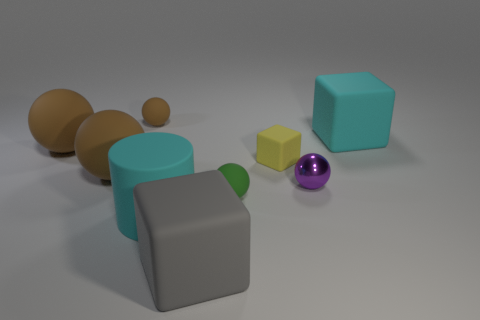Are there any other things that are the same material as the tiny purple sphere?
Give a very brief answer. No. There is a big rubber cylinder; what number of large cyan rubber things are behind it?
Offer a very short reply. 1. How many other things are the same size as the purple object?
Offer a terse response. 3. What is the size of the green rubber object that is the same shape as the small brown thing?
Offer a terse response. Small. What shape is the matte object that is right of the tiny purple shiny sphere?
Provide a short and direct response. Cube. There is a object that is behind the big matte cube behind the large cyan cylinder; what color is it?
Make the answer very short. Brown. How many things are tiny brown rubber objects to the left of the large rubber cylinder or matte spheres?
Provide a succinct answer. 4. Is the size of the cyan cube the same as the green rubber object that is on the left side of the small yellow matte block?
Ensure brevity in your answer.  No. What number of large things are spheres or cylinders?
Give a very brief answer. 3. The small purple shiny thing has what shape?
Your answer should be compact. Sphere. 